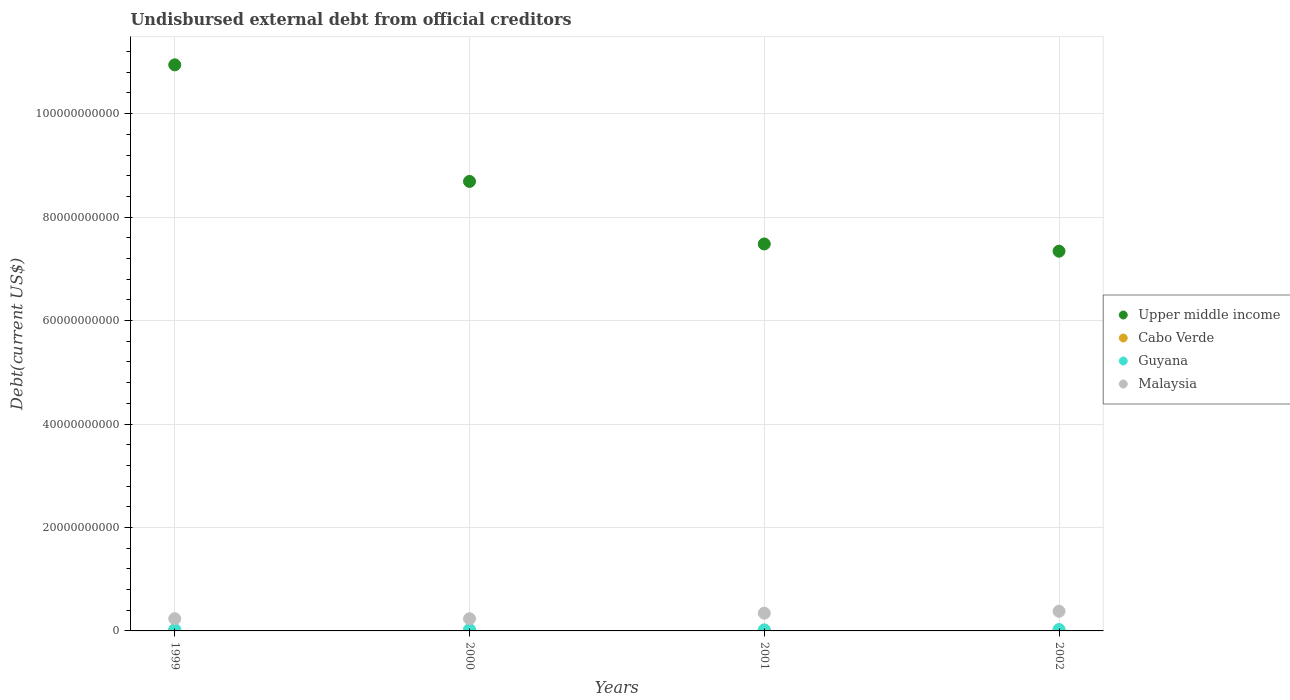What is the total debt in Upper middle income in 2001?
Your answer should be very brief. 7.48e+1. Across all years, what is the maximum total debt in Guyana?
Keep it short and to the point. 2.72e+08. Across all years, what is the minimum total debt in Guyana?
Offer a terse response. 2.00e+08. In which year was the total debt in Guyana maximum?
Your answer should be compact. 2002. What is the total total debt in Upper middle income in the graph?
Provide a succinct answer. 3.45e+11. What is the difference between the total debt in Cabo Verde in 1999 and that in 2002?
Your answer should be compact. 2.44e+07. What is the difference between the total debt in Malaysia in 2002 and the total debt in Upper middle income in 2000?
Offer a terse response. -8.31e+1. What is the average total debt in Malaysia per year?
Provide a short and direct response. 2.98e+09. In the year 2002, what is the difference between the total debt in Malaysia and total debt in Guyana?
Offer a very short reply. 3.52e+09. What is the ratio of the total debt in Guyana in 1999 to that in 2000?
Provide a short and direct response. 0.94. What is the difference between the highest and the second highest total debt in Malaysia?
Keep it short and to the point. 3.70e+08. What is the difference between the highest and the lowest total debt in Cabo Verde?
Your response must be concise. 2.44e+07. Is the sum of the total debt in Malaysia in 1999 and 2002 greater than the maximum total debt in Upper middle income across all years?
Provide a short and direct response. No. Is it the case that in every year, the sum of the total debt in Malaysia and total debt in Cabo Verde  is greater than the sum of total debt in Guyana and total debt in Upper middle income?
Your response must be concise. Yes. How many dotlines are there?
Provide a succinct answer. 4. What is the difference between two consecutive major ticks on the Y-axis?
Offer a terse response. 2.00e+1. Are the values on the major ticks of Y-axis written in scientific E-notation?
Make the answer very short. No. Does the graph contain any zero values?
Your answer should be very brief. No. Does the graph contain grids?
Ensure brevity in your answer.  Yes. Where does the legend appear in the graph?
Make the answer very short. Center right. How many legend labels are there?
Offer a terse response. 4. What is the title of the graph?
Keep it short and to the point. Undisbursed external debt from official creditors. What is the label or title of the X-axis?
Your answer should be compact. Years. What is the label or title of the Y-axis?
Give a very brief answer. Debt(current US$). What is the Debt(current US$) of Upper middle income in 1999?
Provide a short and direct response. 1.09e+11. What is the Debt(current US$) of Cabo Verde in 1999?
Offer a very short reply. 1.53e+08. What is the Debt(current US$) in Guyana in 1999?
Your answer should be very brief. 2.46e+08. What is the Debt(current US$) in Malaysia in 1999?
Offer a very short reply. 2.36e+09. What is the Debt(current US$) of Upper middle income in 2000?
Provide a short and direct response. 8.69e+1. What is the Debt(current US$) of Cabo Verde in 2000?
Make the answer very short. 1.37e+08. What is the Debt(current US$) of Guyana in 2000?
Make the answer very short. 2.62e+08. What is the Debt(current US$) of Malaysia in 2000?
Provide a succinct answer. 2.35e+09. What is the Debt(current US$) of Upper middle income in 2001?
Your answer should be very brief. 7.48e+1. What is the Debt(current US$) of Cabo Verde in 2001?
Your answer should be compact. 1.29e+08. What is the Debt(current US$) of Guyana in 2001?
Make the answer very short. 2.00e+08. What is the Debt(current US$) in Malaysia in 2001?
Provide a succinct answer. 3.43e+09. What is the Debt(current US$) of Upper middle income in 2002?
Ensure brevity in your answer.  7.34e+1. What is the Debt(current US$) in Cabo Verde in 2002?
Your response must be concise. 1.28e+08. What is the Debt(current US$) in Guyana in 2002?
Your answer should be compact. 2.72e+08. What is the Debt(current US$) in Malaysia in 2002?
Your answer should be very brief. 3.80e+09. Across all years, what is the maximum Debt(current US$) in Upper middle income?
Ensure brevity in your answer.  1.09e+11. Across all years, what is the maximum Debt(current US$) of Cabo Verde?
Offer a terse response. 1.53e+08. Across all years, what is the maximum Debt(current US$) in Guyana?
Make the answer very short. 2.72e+08. Across all years, what is the maximum Debt(current US$) in Malaysia?
Offer a very short reply. 3.80e+09. Across all years, what is the minimum Debt(current US$) in Upper middle income?
Give a very brief answer. 7.34e+1. Across all years, what is the minimum Debt(current US$) of Cabo Verde?
Keep it short and to the point. 1.28e+08. Across all years, what is the minimum Debt(current US$) of Guyana?
Give a very brief answer. 2.00e+08. Across all years, what is the minimum Debt(current US$) of Malaysia?
Offer a terse response. 2.35e+09. What is the total Debt(current US$) of Upper middle income in the graph?
Ensure brevity in your answer.  3.45e+11. What is the total Debt(current US$) of Cabo Verde in the graph?
Ensure brevity in your answer.  5.47e+08. What is the total Debt(current US$) of Guyana in the graph?
Keep it short and to the point. 9.81e+08. What is the total Debt(current US$) in Malaysia in the graph?
Offer a very short reply. 1.19e+1. What is the difference between the Debt(current US$) in Upper middle income in 1999 and that in 2000?
Your answer should be very brief. 2.25e+1. What is the difference between the Debt(current US$) of Cabo Verde in 1999 and that in 2000?
Provide a short and direct response. 1.56e+07. What is the difference between the Debt(current US$) of Guyana in 1999 and that in 2000?
Provide a short and direct response. -1.65e+07. What is the difference between the Debt(current US$) in Malaysia in 1999 and that in 2000?
Provide a short and direct response. 6.34e+06. What is the difference between the Debt(current US$) of Upper middle income in 1999 and that in 2001?
Your answer should be very brief. 3.46e+1. What is the difference between the Debt(current US$) in Cabo Verde in 1999 and that in 2001?
Your answer should be very brief. 2.38e+07. What is the difference between the Debt(current US$) in Guyana in 1999 and that in 2001?
Provide a succinct answer. 4.55e+07. What is the difference between the Debt(current US$) of Malaysia in 1999 and that in 2001?
Keep it short and to the point. -1.07e+09. What is the difference between the Debt(current US$) in Upper middle income in 1999 and that in 2002?
Provide a succinct answer. 3.60e+1. What is the difference between the Debt(current US$) in Cabo Verde in 1999 and that in 2002?
Offer a terse response. 2.44e+07. What is the difference between the Debt(current US$) of Guyana in 1999 and that in 2002?
Offer a very short reply. -2.63e+07. What is the difference between the Debt(current US$) of Malaysia in 1999 and that in 2002?
Provide a succinct answer. -1.43e+09. What is the difference between the Debt(current US$) in Upper middle income in 2000 and that in 2001?
Offer a very short reply. 1.21e+1. What is the difference between the Debt(current US$) in Cabo Verde in 2000 and that in 2001?
Your answer should be compact. 8.25e+06. What is the difference between the Debt(current US$) of Guyana in 2000 and that in 2001?
Offer a terse response. 6.20e+07. What is the difference between the Debt(current US$) of Malaysia in 2000 and that in 2001?
Offer a very short reply. -1.07e+09. What is the difference between the Debt(current US$) of Upper middle income in 2000 and that in 2002?
Give a very brief answer. 1.35e+1. What is the difference between the Debt(current US$) in Cabo Verde in 2000 and that in 2002?
Offer a terse response. 8.82e+06. What is the difference between the Debt(current US$) of Guyana in 2000 and that in 2002?
Ensure brevity in your answer.  -9.77e+06. What is the difference between the Debt(current US$) of Malaysia in 2000 and that in 2002?
Your response must be concise. -1.44e+09. What is the difference between the Debt(current US$) in Upper middle income in 2001 and that in 2002?
Give a very brief answer. 1.40e+09. What is the difference between the Debt(current US$) in Cabo Verde in 2001 and that in 2002?
Your response must be concise. 5.68e+05. What is the difference between the Debt(current US$) in Guyana in 2001 and that in 2002?
Make the answer very short. -7.18e+07. What is the difference between the Debt(current US$) in Malaysia in 2001 and that in 2002?
Your answer should be compact. -3.70e+08. What is the difference between the Debt(current US$) in Upper middle income in 1999 and the Debt(current US$) in Cabo Verde in 2000?
Provide a short and direct response. 1.09e+11. What is the difference between the Debt(current US$) in Upper middle income in 1999 and the Debt(current US$) in Guyana in 2000?
Your answer should be compact. 1.09e+11. What is the difference between the Debt(current US$) of Upper middle income in 1999 and the Debt(current US$) of Malaysia in 2000?
Offer a terse response. 1.07e+11. What is the difference between the Debt(current US$) in Cabo Verde in 1999 and the Debt(current US$) in Guyana in 2000?
Your answer should be compact. -1.10e+08. What is the difference between the Debt(current US$) of Cabo Verde in 1999 and the Debt(current US$) of Malaysia in 2000?
Offer a very short reply. -2.20e+09. What is the difference between the Debt(current US$) in Guyana in 1999 and the Debt(current US$) in Malaysia in 2000?
Give a very brief answer. -2.11e+09. What is the difference between the Debt(current US$) in Upper middle income in 1999 and the Debt(current US$) in Cabo Verde in 2001?
Give a very brief answer. 1.09e+11. What is the difference between the Debt(current US$) in Upper middle income in 1999 and the Debt(current US$) in Guyana in 2001?
Provide a short and direct response. 1.09e+11. What is the difference between the Debt(current US$) of Upper middle income in 1999 and the Debt(current US$) of Malaysia in 2001?
Your answer should be compact. 1.06e+11. What is the difference between the Debt(current US$) in Cabo Verde in 1999 and the Debt(current US$) in Guyana in 2001?
Offer a very short reply. -4.77e+07. What is the difference between the Debt(current US$) of Cabo Verde in 1999 and the Debt(current US$) of Malaysia in 2001?
Offer a terse response. -3.27e+09. What is the difference between the Debt(current US$) in Guyana in 1999 and the Debt(current US$) in Malaysia in 2001?
Offer a very short reply. -3.18e+09. What is the difference between the Debt(current US$) in Upper middle income in 1999 and the Debt(current US$) in Cabo Verde in 2002?
Ensure brevity in your answer.  1.09e+11. What is the difference between the Debt(current US$) of Upper middle income in 1999 and the Debt(current US$) of Guyana in 2002?
Your answer should be compact. 1.09e+11. What is the difference between the Debt(current US$) in Upper middle income in 1999 and the Debt(current US$) in Malaysia in 2002?
Your response must be concise. 1.06e+11. What is the difference between the Debt(current US$) in Cabo Verde in 1999 and the Debt(current US$) in Guyana in 2002?
Give a very brief answer. -1.19e+08. What is the difference between the Debt(current US$) of Cabo Verde in 1999 and the Debt(current US$) of Malaysia in 2002?
Provide a short and direct response. -3.64e+09. What is the difference between the Debt(current US$) of Guyana in 1999 and the Debt(current US$) of Malaysia in 2002?
Your response must be concise. -3.55e+09. What is the difference between the Debt(current US$) in Upper middle income in 2000 and the Debt(current US$) in Cabo Verde in 2001?
Provide a short and direct response. 8.68e+1. What is the difference between the Debt(current US$) in Upper middle income in 2000 and the Debt(current US$) in Guyana in 2001?
Your response must be concise. 8.67e+1. What is the difference between the Debt(current US$) of Upper middle income in 2000 and the Debt(current US$) of Malaysia in 2001?
Make the answer very short. 8.35e+1. What is the difference between the Debt(current US$) of Cabo Verde in 2000 and the Debt(current US$) of Guyana in 2001?
Give a very brief answer. -6.33e+07. What is the difference between the Debt(current US$) in Cabo Verde in 2000 and the Debt(current US$) in Malaysia in 2001?
Your answer should be compact. -3.29e+09. What is the difference between the Debt(current US$) of Guyana in 2000 and the Debt(current US$) of Malaysia in 2001?
Your answer should be compact. -3.16e+09. What is the difference between the Debt(current US$) of Upper middle income in 2000 and the Debt(current US$) of Cabo Verde in 2002?
Provide a short and direct response. 8.68e+1. What is the difference between the Debt(current US$) of Upper middle income in 2000 and the Debt(current US$) of Guyana in 2002?
Offer a terse response. 8.66e+1. What is the difference between the Debt(current US$) of Upper middle income in 2000 and the Debt(current US$) of Malaysia in 2002?
Ensure brevity in your answer.  8.31e+1. What is the difference between the Debt(current US$) in Cabo Verde in 2000 and the Debt(current US$) in Guyana in 2002?
Ensure brevity in your answer.  -1.35e+08. What is the difference between the Debt(current US$) in Cabo Verde in 2000 and the Debt(current US$) in Malaysia in 2002?
Offer a terse response. -3.66e+09. What is the difference between the Debt(current US$) of Guyana in 2000 and the Debt(current US$) of Malaysia in 2002?
Give a very brief answer. -3.53e+09. What is the difference between the Debt(current US$) in Upper middle income in 2001 and the Debt(current US$) in Cabo Verde in 2002?
Your answer should be compact. 7.47e+1. What is the difference between the Debt(current US$) in Upper middle income in 2001 and the Debt(current US$) in Guyana in 2002?
Your response must be concise. 7.45e+1. What is the difference between the Debt(current US$) of Upper middle income in 2001 and the Debt(current US$) of Malaysia in 2002?
Your answer should be compact. 7.10e+1. What is the difference between the Debt(current US$) in Cabo Verde in 2001 and the Debt(current US$) in Guyana in 2002?
Your answer should be very brief. -1.43e+08. What is the difference between the Debt(current US$) of Cabo Verde in 2001 and the Debt(current US$) of Malaysia in 2002?
Ensure brevity in your answer.  -3.67e+09. What is the difference between the Debt(current US$) of Guyana in 2001 and the Debt(current US$) of Malaysia in 2002?
Give a very brief answer. -3.60e+09. What is the average Debt(current US$) in Upper middle income per year?
Give a very brief answer. 8.61e+1. What is the average Debt(current US$) in Cabo Verde per year?
Your answer should be very brief. 1.37e+08. What is the average Debt(current US$) in Guyana per year?
Offer a terse response. 2.45e+08. What is the average Debt(current US$) of Malaysia per year?
Make the answer very short. 2.98e+09. In the year 1999, what is the difference between the Debt(current US$) in Upper middle income and Debt(current US$) in Cabo Verde?
Keep it short and to the point. 1.09e+11. In the year 1999, what is the difference between the Debt(current US$) of Upper middle income and Debt(current US$) of Guyana?
Your answer should be compact. 1.09e+11. In the year 1999, what is the difference between the Debt(current US$) of Upper middle income and Debt(current US$) of Malaysia?
Keep it short and to the point. 1.07e+11. In the year 1999, what is the difference between the Debt(current US$) in Cabo Verde and Debt(current US$) in Guyana?
Offer a very short reply. -9.32e+07. In the year 1999, what is the difference between the Debt(current US$) of Cabo Verde and Debt(current US$) of Malaysia?
Provide a succinct answer. -2.21e+09. In the year 1999, what is the difference between the Debt(current US$) of Guyana and Debt(current US$) of Malaysia?
Keep it short and to the point. -2.12e+09. In the year 2000, what is the difference between the Debt(current US$) in Upper middle income and Debt(current US$) in Cabo Verde?
Your answer should be very brief. 8.68e+1. In the year 2000, what is the difference between the Debt(current US$) in Upper middle income and Debt(current US$) in Guyana?
Provide a short and direct response. 8.66e+1. In the year 2000, what is the difference between the Debt(current US$) of Upper middle income and Debt(current US$) of Malaysia?
Provide a succinct answer. 8.45e+1. In the year 2000, what is the difference between the Debt(current US$) in Cabo Verde and Debt(current US$) in Guyana?
Offer a terse response. -1.25e+08. In the year 2000, what is the difference between the Debt(current US$) in Cabo Verde and Debt(current US$) in Malaysia?
Ensure brevity in your answer.  -2.22e+09. In the year 2000, what is the difference between the Debt(current US$) of Guyana and Debt(current US$) of Malaysia?
Ensure brevity in your answer.  -2.09e+09. In the year 2001, what is the difference between the Debt(current US$) in Upper middle income and Debt(current US$) in Cabo Verde?
Offer a very short reply. 7.47e+1. In the year 2001, what is the difference between the Debt(current US$) of Upper middle income and Debt(current US$) of Guyana?
Offer a terse response. 7.46e+1. In the year 2001, what is the difference between the Debt(current US$) in Upper middle income and Debt(current US$) in Malaysia?
Keep it short and to the point. 7.14e+1. In the year 2001, what is the difference between the Debt(current US$) of Cabo Verde and Debt(current US$) of Guyana?
Offer a very short reply. -7.15e+07. In the year 2001, what is the difference between the Debt(current US$) of Cabo Verde and Debt(current US$) of Malaysia?
Your response must be concise. -3.30e+09. In the year 2001, what is the difference between the Debt(current US$) of Guyana and Debt(current US$) of Malaysia?
Provide a short and direct response. -3.23e+09. In the year 2002, what is the difference between the Debt(current US$) in Upper middle income and Debt(current US$) in Cabo Verde?
Offer a terse response. 7.33e+1. In the year 2002, what is the difference between the Debt(current US$) of Upper middle income and Debt(current US$) of Guyana?
Make the answer very short. 7.31e+1. In the year 2002, what is the difference between the Debt(current US$) of Upper middle income and Debt(current US$) of Malaysia?
Ensure brevity in your answer.  6.96e+1. In the year 2002, what is the difference between the Debt(current US$) in Cabo Verde and Debt(current US$) in Guyana?
Make the answer very short. -1.44e+08. In the year 2002, what is the difference between the Debt(current US$) of Cabo Verde and Debt(current US$) of Malaysia?
Your response must be concise. -3.67e+09. In the year 2002, what is the difference between the Debt(current US$) of Guyana and Debt(current US$) of Malaysia?
Offer a terse response. -3.52e+09. What is the ratio of the Debt(current US$) of Upper middle income in 1999 to that in 2000?
Your answer should be very brief. 1.26. What is the ratio of the Debt(current US$) in Cabo Verde in 1999 to that in 2000?
Offer a terse response. 1.11. What is the ratio of the Debt(current US$) of Guyana in 1999 to that in 2000?
Provide a short and direct response. 0.94. What is the ratio of the Debt(current US$) of Malaysia in 1999 to that in 2000?
Ensure brevity in your answer.  1. What is the ratio of the Debt(current US$) of Upper middle income in 1999 to that in 2001?
Provide a succinct answer. 1.46. What is the ratio of the Debt(current US$) of Cabo Verde in 1999 to that in 2001?
Provide a short and direct response. 1.18. What is the ratio of the Debt(current US$) in Guyana in 1999 to that in 2001?
Make the answer very short. 1.23. What is the ratio of the Debt(current US$) in Malaysia in 1999 to that in 2001?
Give a very brief answer. 0.69. What is the ratio of the Debt(current US$) in Upper middle income in 1999 to that in 2002?
Keep it short and to the point. 1.49. What is the ratio of the Debt(current US$) of Cabo Verde in 1999 to that in 2002?
Make the answer very short. 1.19. What is the ratio of the Debt(current US$) of Guyana in 1999 to that in 2002?
Keep it short and to the point. 0.9. What is the ratio of the Debt(current US$) of Malaysia in 1999 to that in 2002?
Ensure brevity in your answer.  0.62. What is the ratio of the Debt(current US$) in Upper middle income in 2000 to that in 2001?
Give a very brief answer. 1.16. What is the ratio of the Debt(current US$) of Cabo Verde in 2000 to that in 2001?
Your response must be concise. 1.06. What is the ratio of the Debt(current US$) of Guyana in 2000 to that in 2001?
Give a very brief answer. 1.31. What is the ratio of the Debt(current US$) in Malaysia in 2000 to that in 2001?
Offer a very short reply. 0.69. What is the ratio of the Debt(current US$) of Upper middle income in 2000 to that in 2002?
Provide a succinct answer. 1.18. What is the ratio of the Debt(current US$) of Cabo Verde in 2000 to that in 2002?
Your answer should be compact. 1.07. What is the ratio of the Debt(current US$) in Guyana in 2000 to that in 2002?
Your answer should be compact. 0.96. What is the ratio of the Debt(current US$) in Malaysia in 2000 to that in 2002?
Offer a very short reply. 0.62. What is the ratio of the Debt(current US$) of Upper middle income in 2001 to that in 2002?
Provide a succinct answer. 1.02. What is the ratio of the Debt(current US$) in Cabo Verde in 2001 to that in 2002?
Offer a terse response. 1. What is the ratio of the Debt(current US$) of Guyana in 2001 to that in 2002?
Your answer should be compact. 0.74. What is the ratio of the Debt(current US$) of Malaysia in 2001 to that in 2002?
Offer a terse response. 0.9. What is the difference between the highest and the second highest Debt(current US$) in Upper middle income?
Your answer should be compact. 2.25e+1. What is the difference between the highest and the second highest Debt(current US$) in Cabo Verde?
Provide a succinct answer. 1.56e+07. What is the difference between the highest and the second highest Debt(current US$) of Guyana?
Give a very brief answer. 9.77e+06. What is the difference between the highest and the second highest Debt(current US$) in Malaysia?
Your response must be concise. 3.70e+08. What is the difference between the highest and the lowest Debt(current US$) in Upper middle income?
Make the answer very short. 3.60e+1. What is the difference between the highest and the lowest Debt(current US$) of Cabo Verde?
Offer a very short reply. 2.44e+07. What is the difference between the highest and the lowest Debt(current US$) of Guyana?
Keep it short and to the point. 7.18e+07. What is the difference between the highest and the lowest Debt(current US$) in Malaysia?
Provide a succinct answer. 1.44e+09. 